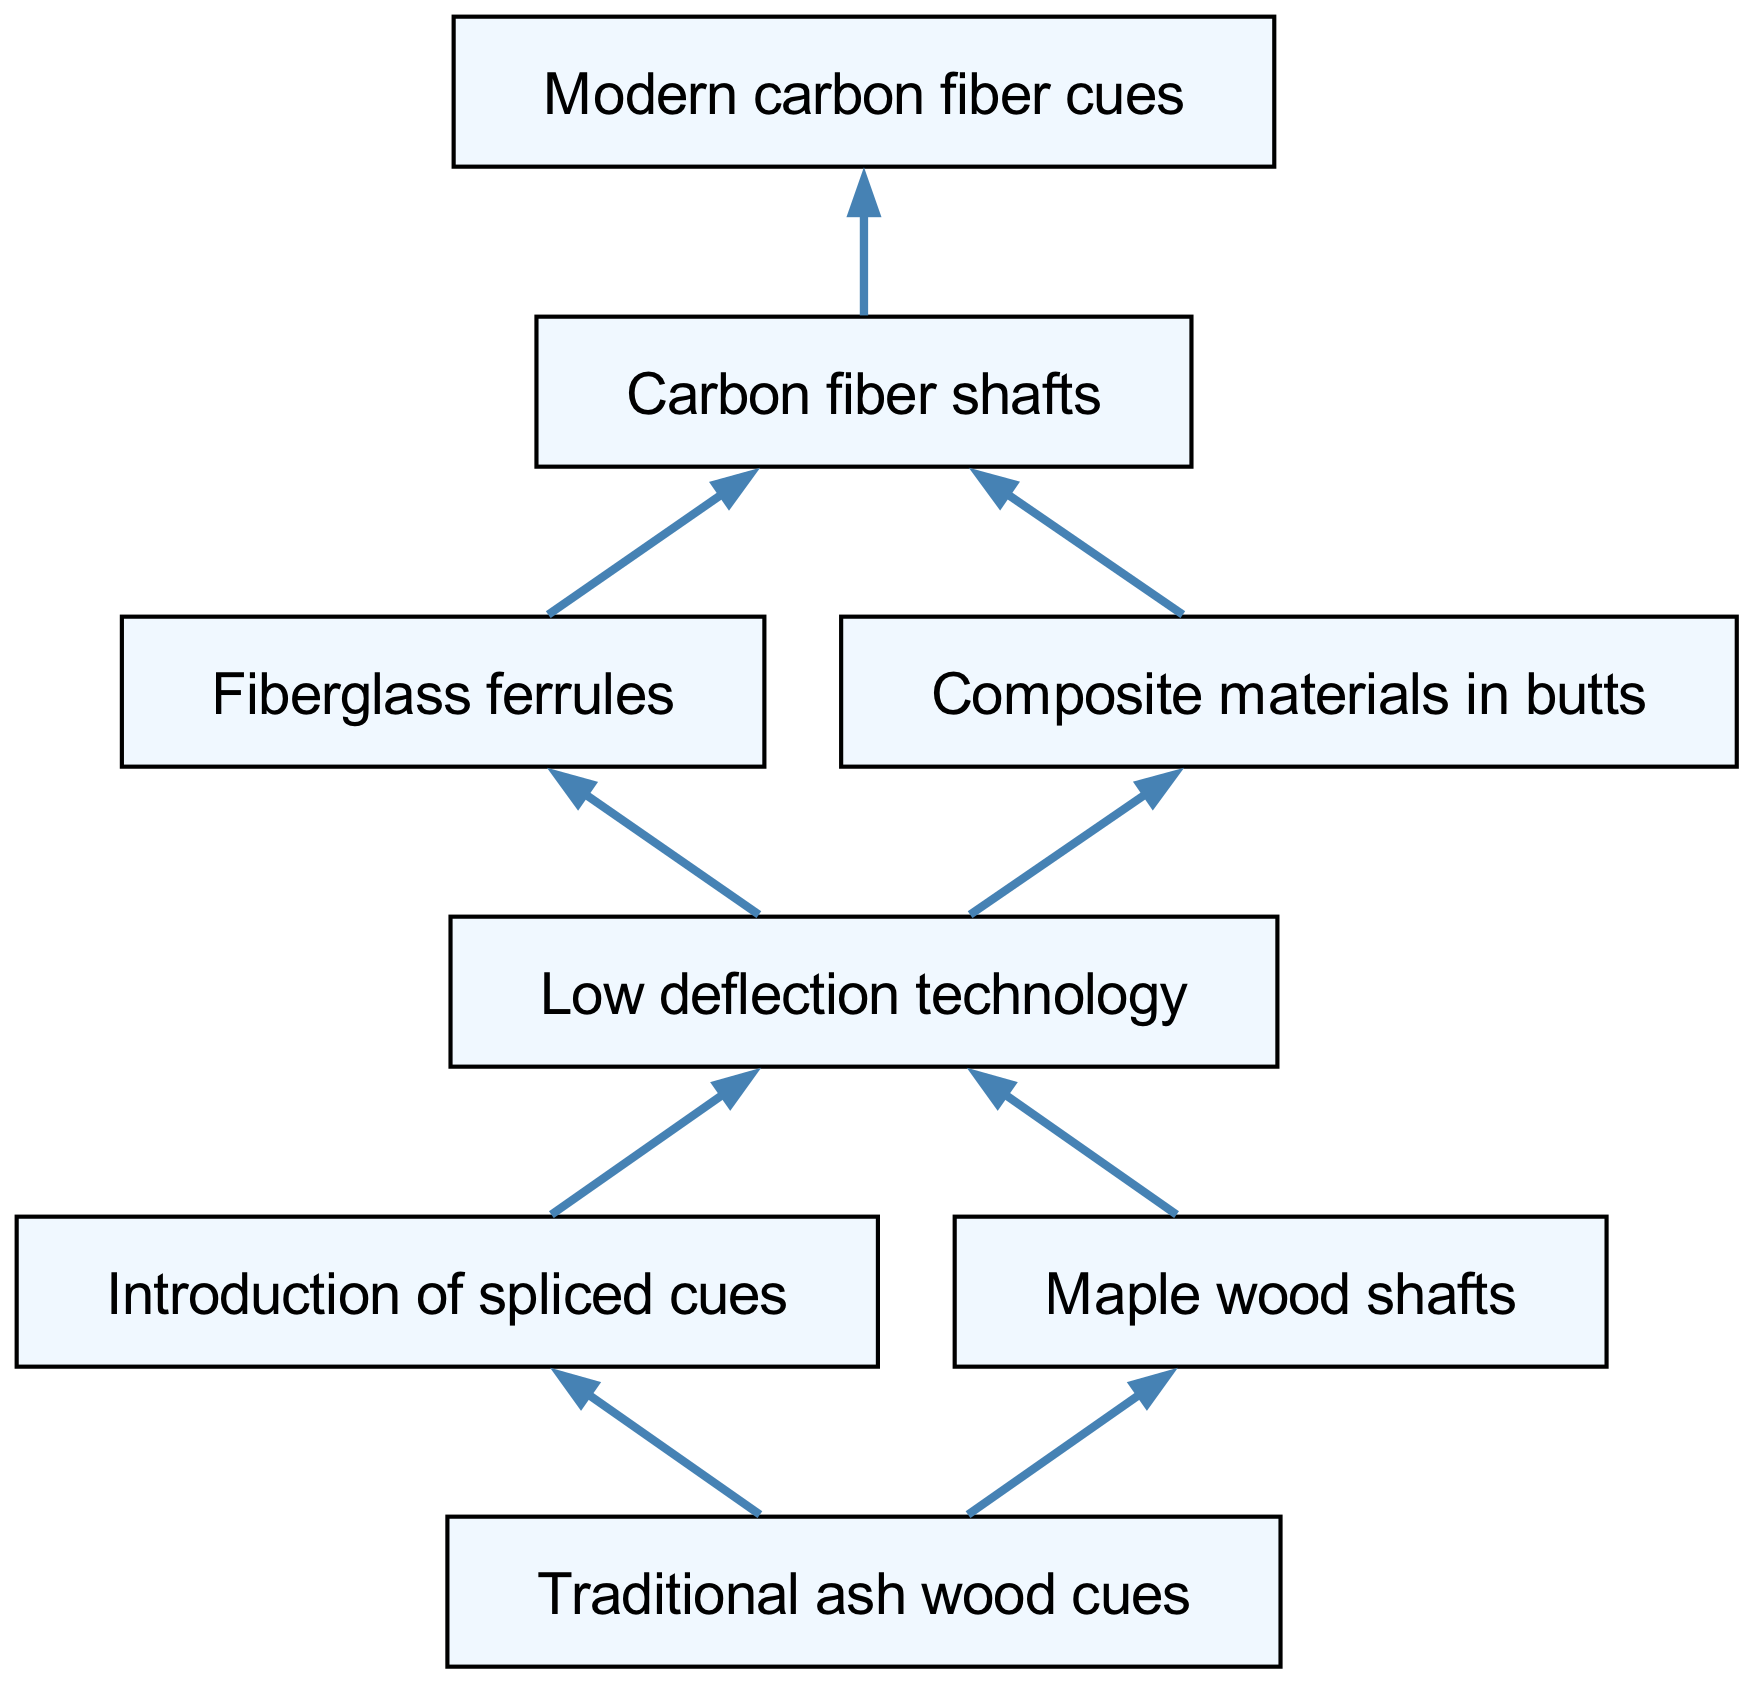What is the first node in the diagram? The first node is "Traditional ash wood cues," which is the starting point of the flowchart.
Answer: Traditional ash wood cues How many nodes are in the diagram? By counting all the unique elements in the diagram, there are a total of 8 nodes.
Answer: 8 What are the two types of wood mentioned in the nodes? The nodes refer to "ash" in traditional cues and "maple" in one of the shafts, indicating the types of wood used prior to modern advancements.
Answer: Ash and Maple What technological development follows "Low deflection technology"? The node that comes directly after "Low deflection technology" is "Carbon fiber shafts," indicating the progression of technology.
Answer: Carbon fiber shafts Which nodes are connected to "Low deflection technology"? The "Low deflection technology" node has connections to "Fiberglass ferrules" and "Composite materials in butts," indicating the subsequent developments stemming from it.
Answer: Fiberglass ferrules, Composite materials in butts What is the final node in the evolution of snooker cue technology? The last node in the flowchart signifies the culmination of all developments into "Modern carbon fiber cues."
Answer: Modern carbon fiber cues How many edges emanate from "Traditional ash wood cues"? Upon examining the connections of "Traditional ash wood cues," it is connected to two subsequent nodes, leading to a total of 2 edges.
Answer: 2 What type of materials are introduced in the node that follows "Fiberglass ferrules"? The next node after "Fiberglass ferrules" is "Carbon fiber shafts," which reflects an advancement in material technology for cues.
Answer: Carbon fiber shafts What development directly leads to "Modern carbon fiber cues"? The "Carbon fiber shafts" node transitions directly into the "Modern carbon fiber cues," showcasing the final technological leap in cue designs.
Answer: Carbon fiber shafts 